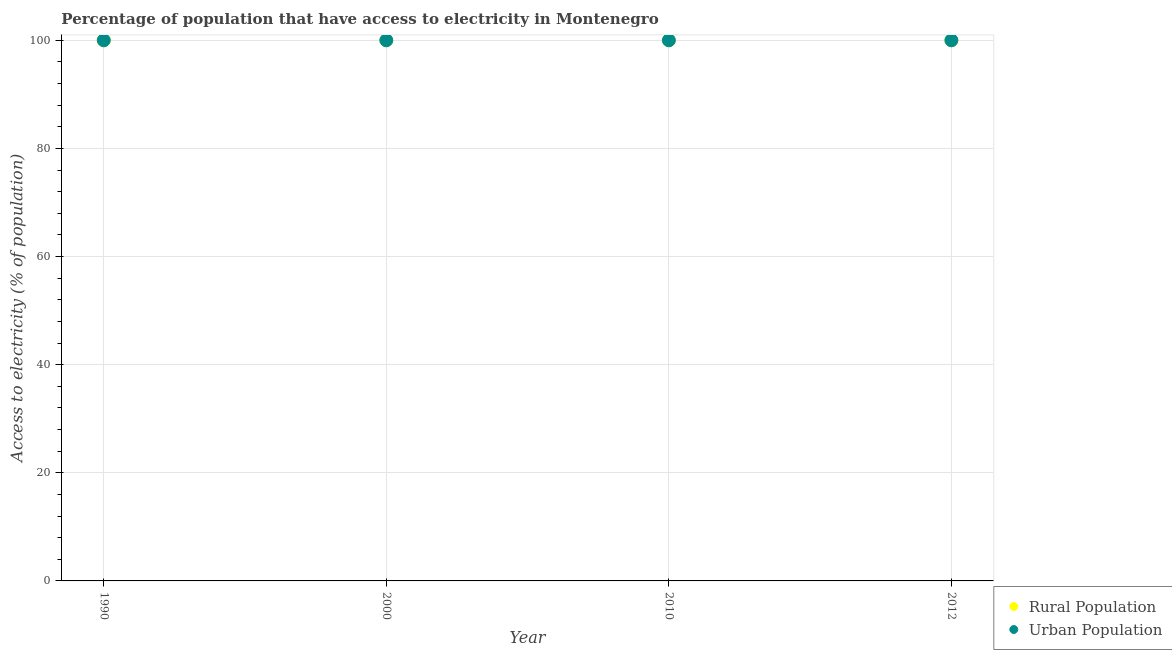Is the number of dotlines equal to the number of legend labels?
Keep it short and to the point. Yes. What is the percentage of urban population having access to electricity in 2000?
Your answer should be compact. 100. Across all years, what is the maximum percentage of urban population having access to electricity?
Your answer should be very brief. 100. Across all years, what is the minimum percentage of rural population having access to electricity?
Make the answer very short. 100. In which year was the percentage of rural population having access to electricity minimum?
Offer a very short reply. 1990. What is the total percentage of rural population having access to electricity in the graph?
Your answer should be very brief. 400. What is the difference between the percentage of urban population having access to electricity in 1990 and that in 2010?
Offer a terse response. 0. What is the difference between the percentage of rural population having access to electricity in 2010 and the percentage of urban population having access to electricity in 2012?
Give a very brief answer. 0. In the year 2012, what is the difference between the percentage of urban population having access to electricity and percentage of rural population having access to electricity?
Your response must be concise. 0. What is the ratio of the percentage of rural population having access to electricity in 1990 to that in 2012?
Your answer should be compact. 1. Is the percentage of rural population having access to electricity in 1990 less than that in 2010?
Provide a short and direct response. No. Is the difference between the percentage of urban population having access to electricity in 1990 and 2012 greater than the difference between the percentage of rural population having access to electricity in 1990 and 2012?
Make the answer very short. No. What is the difference between the highest and the second highest percentage of urban population having access to electricity?
Make the answer very short. 0. What is the difference between the highest and the lowest percentage of rural population having access to electricity?
Offer a very short reply. 0. Is the percentage of urban population having access to electricity strictly less than the percentage of rural population having access to electricity over the years?
Your response must be concise. No. How many years are there in the graph?
Your answer should be compact. 4. Are the values on the major ticks of Y-axis written in scientific E-notation?
Your answer should be compact. No. Does the graph contain any zero values?
Offer a very short reply. No. How many legend labels are there?
Offer a terse response. 2. How are the legend labels stacked?
Your answer should be very brief. Vertical. What is the title of the graph?
Your answer should be very brief. Percentage of population that have access to electricity in Montenegro. Does "Net savings(excluding particulate emission damage)" appear as one of the legend labels in the graph?
Ensure brevity in your answer.  No. What is the label or title of the Y-axis?
Give a very brief answer. Access to electricity (% of population). What is the Access to electricity (% of population) in Rural Population in 1990?
Your answer should be compact. 100. What is the Access to electricity (% of population) of Urban Population in 1990?
Your answer should be compact. 100. What is the Access to electricity (% of population) in Rural Population in 2000?
Your response must be concise. 100. What is the Access to electricity (% of population) of Urban Population in 2010?
Keep it short and to the point. 100. What is the Access to electricity (% of population) of Urban Population in 2012?
Provide a short and direct response. 100. Across all years, what is the maximum Access to electricity (% of population) in Urban Population?
Offer a terse response. 100. Across all years, what is the minimum Access to electricity (% of population) in Rural Population?
Give a very brief answer. 100. What is the difference between the Access to electricity (% of population) of Urban Population in 1990 and that in 2000?
Give a very brief answer. 0. What is the difference between the Access to electricity (% of population) of Rural Population in 1990 and that in 2010?
Provide a succinct answer. 0. What is the difference between the Access to electricity (% of population) of Rural Population in 1990 and that in 2012?
Provide a short and direct response. 0. What is the difference between the Access to electricity (% of population) in Urban Population in 2000 and that in 2012?
Provide a short and direct response. 0. What is the difference between the Access to electricity (% of population) of Rural Population in 2010 and that in 2012?
Offer a terse response. 0. What is the difference between the Access to electricity (% of population) in Urban Population in 2010 and that in 2012?
Your answer should be compact. 0. What is the difference between the Access to electricity (% of population) of Rural Population in 2010 and the Access to electricity (% of population) of Urban Population in 2012?
Provide a short and direct response. 0. What is the average Access to electricity (% of population) of Urban Population per year?
Ensure brevity in your answer.  100. In the year 1990, what is the difference between the Access to electricity (% of population) of Rural Population and Access to electricity (% of population) of Urban Population?
Make the answer very short. 0. In the year 2000, what is the difference between the Access to electricity (% of population) of Rural Population and Access to electricity (% of population) of Urban Population?
Ensure brevity in your answer.  0. In the year 2012, what is the difference between the Access to electricity (% of population) of Rural Population and Access to electricity (% of population) of Urban Population?
Your response must be concise. 0. What is the ratio of the Access to electricity (% of population) in Urban Population in 1990 to that in 2000?
Make the answer very short. 1. What is the ratio of the Access to electricity (% of population) of Rural Population in 1990 to that in 2010?
Ensure brevity in your answer.  1. What is the ratio of the Access to electricity (% of population) in Urban Population in 1990 to that in 2010?
Your response must be concise. 1. What is the ratio of the Access to electricity (% of population) of Rural Population in 2000 to that in 2010?
Provide a succinct answer. 1. What is the ratio of the Access to electricity (% of population) of Urban Population in 2000 to that in 2010?
Offer a very short reply. 1. What is the ratio of the Access to electricity (% of population) of Rural Population in 2010 to that in 2012?
Provide a short and direct response. 1. What is the difference between the highest and the second highest Access to electricity (% of population) of Urban Population?
Your response must be concise. 0. 